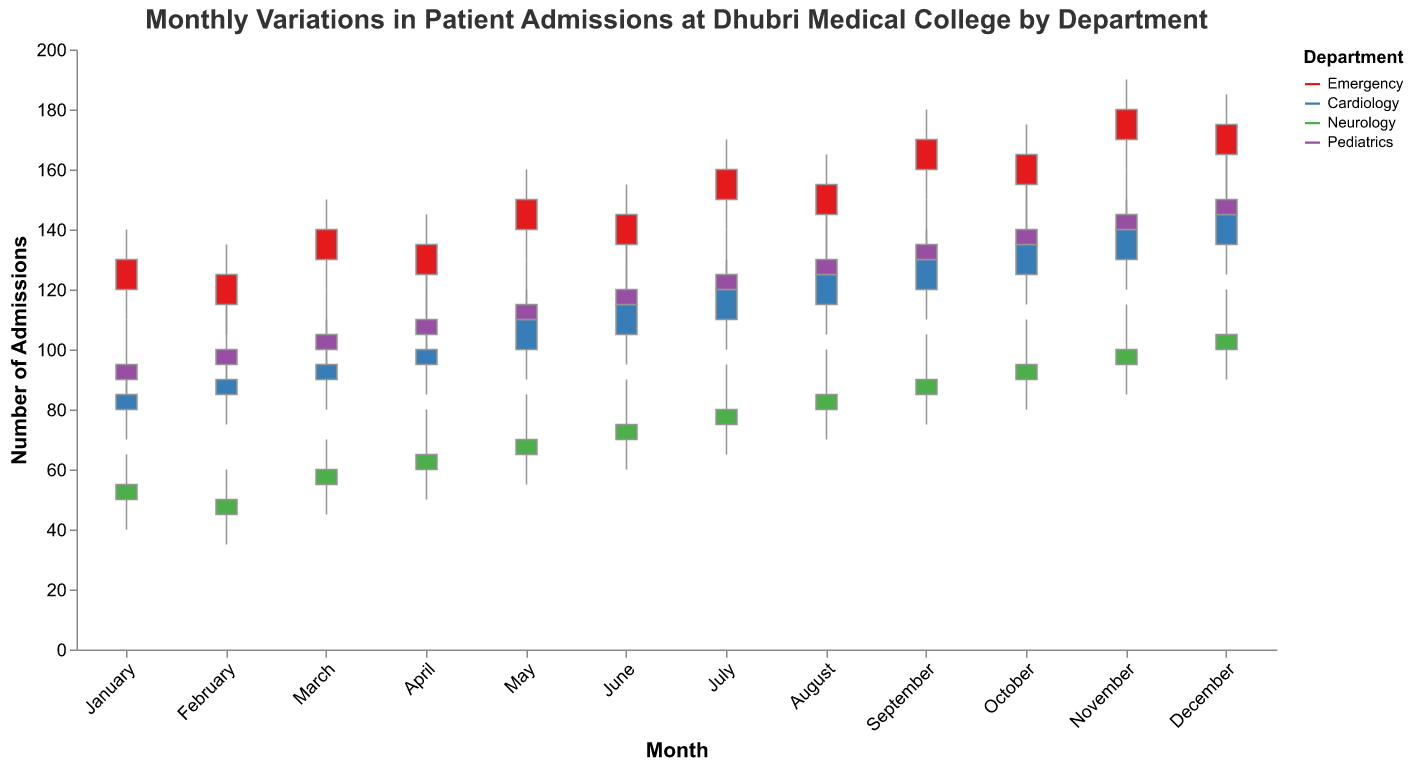How many departments are depicted in the plot? The plot visualizes data for four different departments. The legend on the right specifies them as Emergency, Cardiology, Neurology, and Pediatrics.
Answer: Four What month shows the highest peak for the Emergency department admissions? In the plot, the highest peak for Emergency admissions occurs in November, where the High value reaches 190.
Answer: November During which month does the Cardiology department see the highest number of patient admissions according to the 'Close' value? By observing the 'Close' values for the Cardiology department across all months, the highest 'Close' value is 145 in December.
Answer: December Between which two consecutive months did the Pediatrics department see the highest increase in its 'Open' value? To determine this, we need to compare the 'Open' values month-over-month for the Pediatrics department: 
- January: 90 to February: 95 (increase of 5)
- February: 95 to March: 100 (increase of 5)
- March: 100 to April: 105 (increase of 5)
- April: 105 to May: 110 (increase of 5)
- May: 110 to June: 115 (increase of 5)
- June: 115 to July: 120 (increase of 5)
- July: 120 to August: 125 (increase of 5)
- August: 125 to September: 130 (increase of 5)
- September: 130 to October: 135 (increase of 5)
- October: 135 to November: 140 (increase of 5)
- November: 140 to December: 145 (increase of 5)
All the increases are the same (5), but the highest increase is from September to October for the Pediatrics department, though it is constant across all months presented.
Answer: All are consistent Which department has the lowest 'Low' value for January? By examining the 'Low' values for each department in January: 
- Emergency: 110
- Cardiology: 70
- Neurology: 40
- Pediatrics: 80
The lowest 'Low' value for January is observed in the Neurology department, which is 40.
Answer: Neurology In which month does the Neurology department have the highest 'Close' value? Observing the 'Close' values for the Neurology department across all months:
- January: 55
- February: 50
- March: 60
- April: 65
- May: 70
- June: 75
- July: 80
- August: 85
- September: 90
- October: 95
- November: 100
- December: 105
The highest 'Close' value is 105 in December.
Answer: December Comparing the Emergency department in January and December, which month experienced a greater change (difference) from 'Open' to 'Close' admissions? The change for Emergency in January is abs(Open - Close) = abs(120 - 130) = 10. The change for December is abs(Open - Close) = abs(165 - 175) = 10. Both January and December have the same change, which is 10.
Answer: Both are equal What is the overall trend in 'Close' values for the Cardiology department from January to December? To see the trend in 'Close' values for Cardiology, we can list them down:
- January: 85
- February: 90
- March: 95
- April: 100
- May: 110
- June: 115
- July: 120
- August: 125
- September: 130
- October: 135
- November: 140
- December: 145
The overall trend shows a consistent increase in the 'Close' values from January to December.
Answer: Increasing For the Pediatrics department, during which month is the range (difference between 'High' and 'Low') the smallest? By calculating the range for each month for Pediatrics:
- January: 110 - 80 = 30
- February: 115 - 85 = 30
- March: 120 - 90 = 30
- April: 125 - 95 = 30
- May: 130 - 100 = 30
- June: 135 - 105 = 30
- July: 140 - 110 = 30
- August: 145 - 115 = 30
- September: 150 - 120 = 30
- October: 155 - 125 = 30
- November: 160 - 130 = 30
- December: 165 - 135 = 30
The range is consistently the same (30) for all months presented.
Answer: All are consistent 